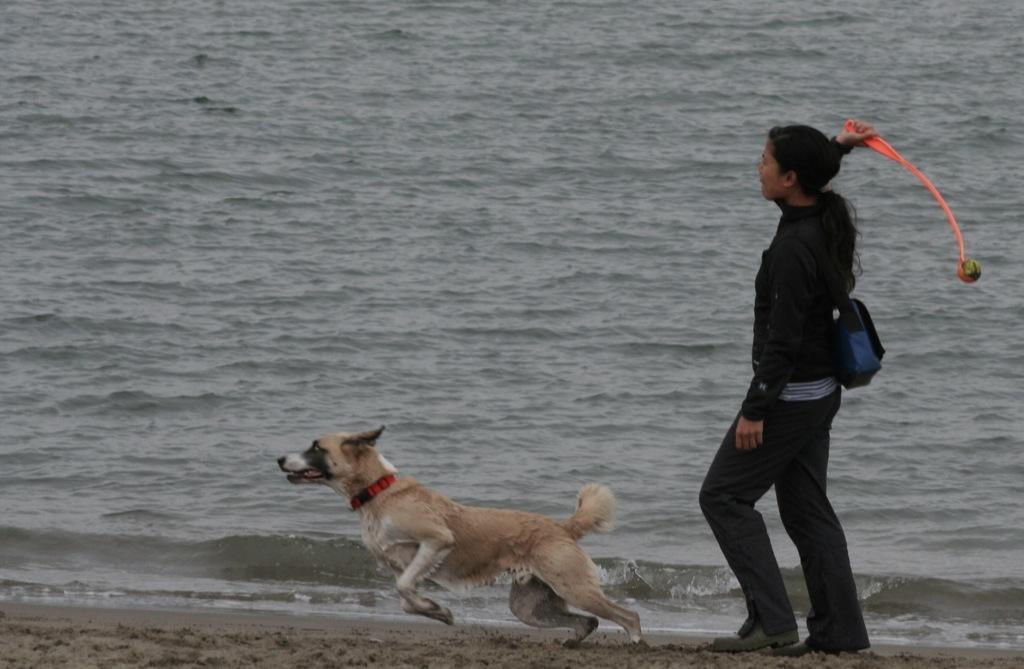Can you describe this image briefly? There is one woman standing and wearing a black color dress and holding an object as we can see on the right side of this image. There is a dog running at the bottom of this image, and there is a surface of water in the background. 